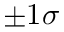<formula> <loc_0><loc_0><loc_500><loc_500>\pm 1 \sigma</formula> 